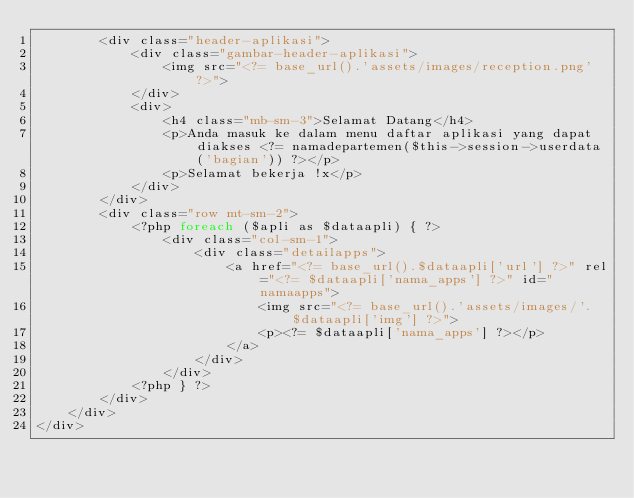<code> <loc_0><loc_0><loc_500><loc_500><_PHP_>		<div class="header-aplikasi">
			<div class="gambar-header-aplikasi">
				<img src="<?= base_url().'assets/images/reception.png' ?>">
			</div>
			<div>
				<h4 class="mb-sm-3">Selamat Datang</h4>
				<p>Anda masuk ke dalam menu daftar aplikasi yang dapat diakses <?= namadepartemen($this->session->userdata('bagian')) ?></p>
				<p>Selamat bekerja !x</p>
			</div>
		</div>
		<div class="row mt-sm-2">
			<?php foreach ($apli as $dataapli) { ?>
				<div class="col-sm-1">
					<div class="detailapps">
						<a href="<?= base_url().$dataapli['url'] ?>" rel="<?= $dataapli['nama_apps'] ?>" id="namaapps">
							<img src="<?= base_url().'assets/images/'.$dataapli['img'] ?>">
							<p><?= $dataapli['nama_apps'] ?></p>
						</a>
					</div>
				</div>	
			<?php } ?>
		</div>
	</div>
</div></code> 